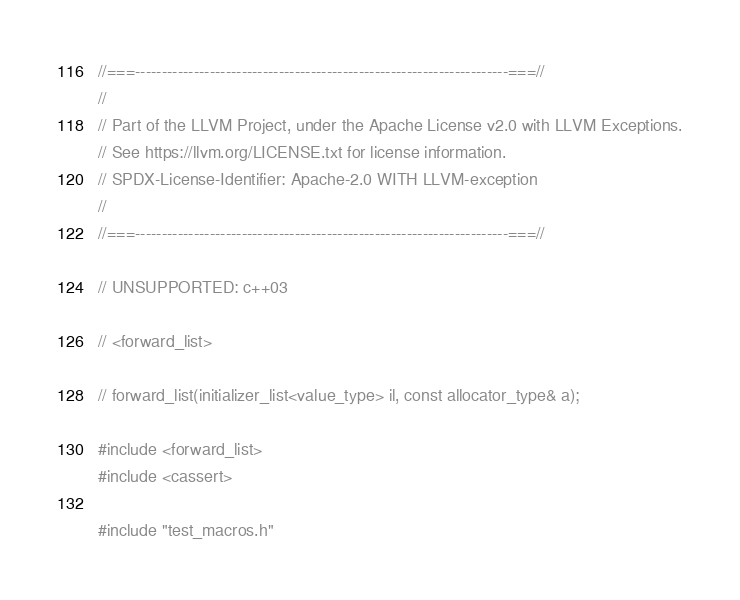Convert code to text. <code><loc_0><loc_0><loc_500><loc_500><_C++_>//===----------------------------------------------------------------------===//
//
// Part of the LLVM Project, under the Apache License v2.0 with LLVM Exceptions.
// See https://llvm.org/LICENSE.txt for license information.
// SPDX-License-Identifier: Apache-2.0 WITH LLVM-exception
//
//===----------------------------------------------------------------------===//

// UNSUPPORTED: c++03

// <forward_list>

// forward_list(initializer_list<value_type> il, const allocator_type& a);

#include <forward_list>
#include <cassert>

#include "test_macros.h"</code> 